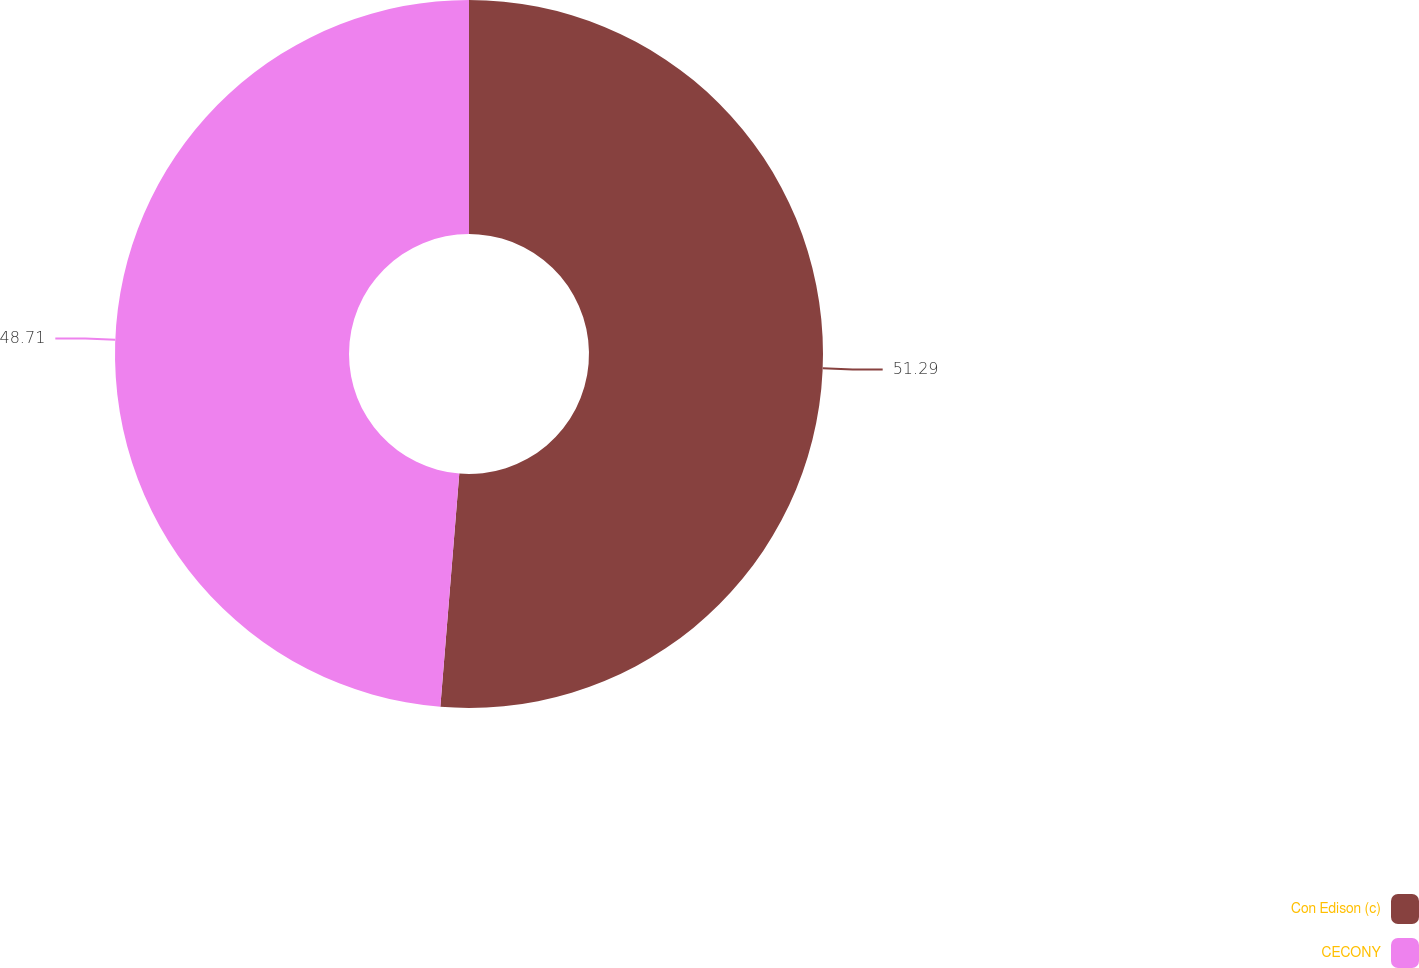<chart> <loc_0><loc_0><loc_500><loc_500><pie_chart><fcel>Con Edison (c)<fcel>CECONY<nl><fcel>51.29%<fcel>48.71%<nl></chart> 